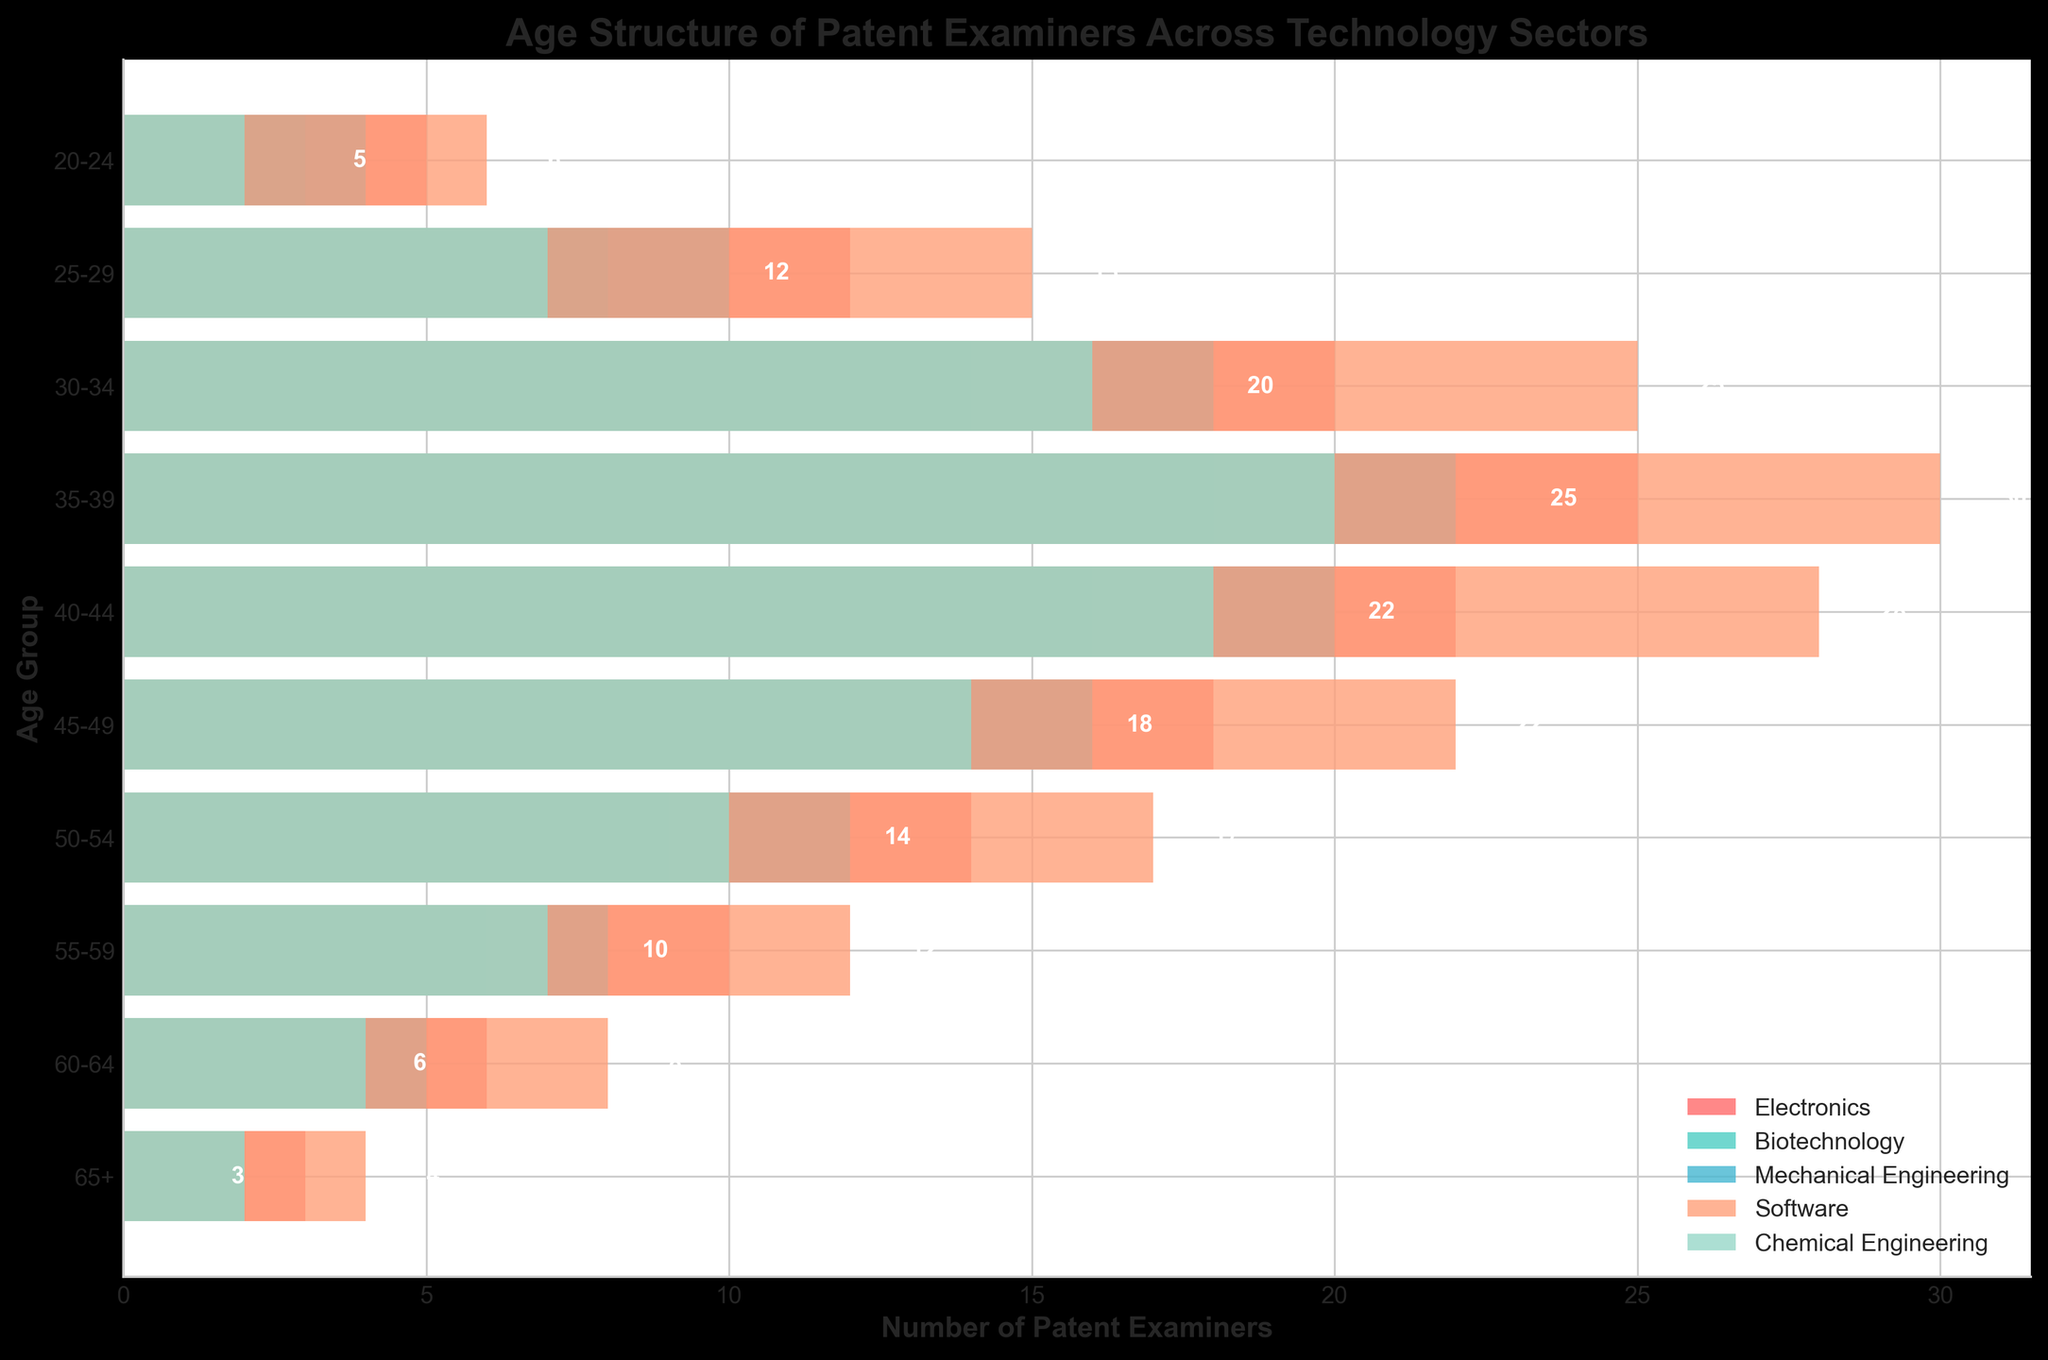How many age groups are represented in the figure? The figure shows bars for different age groups which can be directly counted. There are ten age groups shown in the figure.
Answer: 10 What is the age group with the largest number of Software patent examiners? To find the age group with the largest number of Software patent examiners, identify the bar for Software that extends the furthest to the right. The 35-39 age group has the bar extending to 30, which is the largest.
Answer: 35-39 Which sector has the smallest number of examiners in the 20-24 age group? To determine this, assess the lengths of the bars for each sector in the 20-24 age group. The Chemical Engineering sector has the smallest bar length, at -2.
Answer: Chemical Engineering Which age group has the highest variance in the number of examiners among all sectors? The variance can be intuitively assessed by looking at the bar lengths' differences in each age group. The 35-39 age group shows the highest variance with bars ranging from -25 to 30.
Answer: 35-39 Among examiners aged 40-44, which two sectors have an equal number of examiners? By examining the length and position of bars in the 40-44 age group, we note that both Biotechnology and Chemical Engineering sectors have the same number of examiners, with bars at 16 and -18, respectively.
Answer: Electronics and Chemical Engineering What is the sum total of patent examiners in the 25-29 age group for Biotechnology and Software sectors combined? By adding the respective bar lengths of Biotechnology (8) and Software (15) in the 25-29 age group: 8 + 15 = 23.
Answer: 23 What trend do you observe in the number of Electronics examiners as age increases? By examining the Electronics bars from younger to older age groups, we observe a consistent decrease in numbers as age increases, indicating an aging workforce with fewer younger members joining.
Answer: Decreasing trend Which technology sector has the most balanced age distribution among its examiners? By visually assessing the bars, the Biotechnology sector shows a more balanced distribution, with bars not deviating dramatically from others across most age groups.
Answer: Biotechnology 